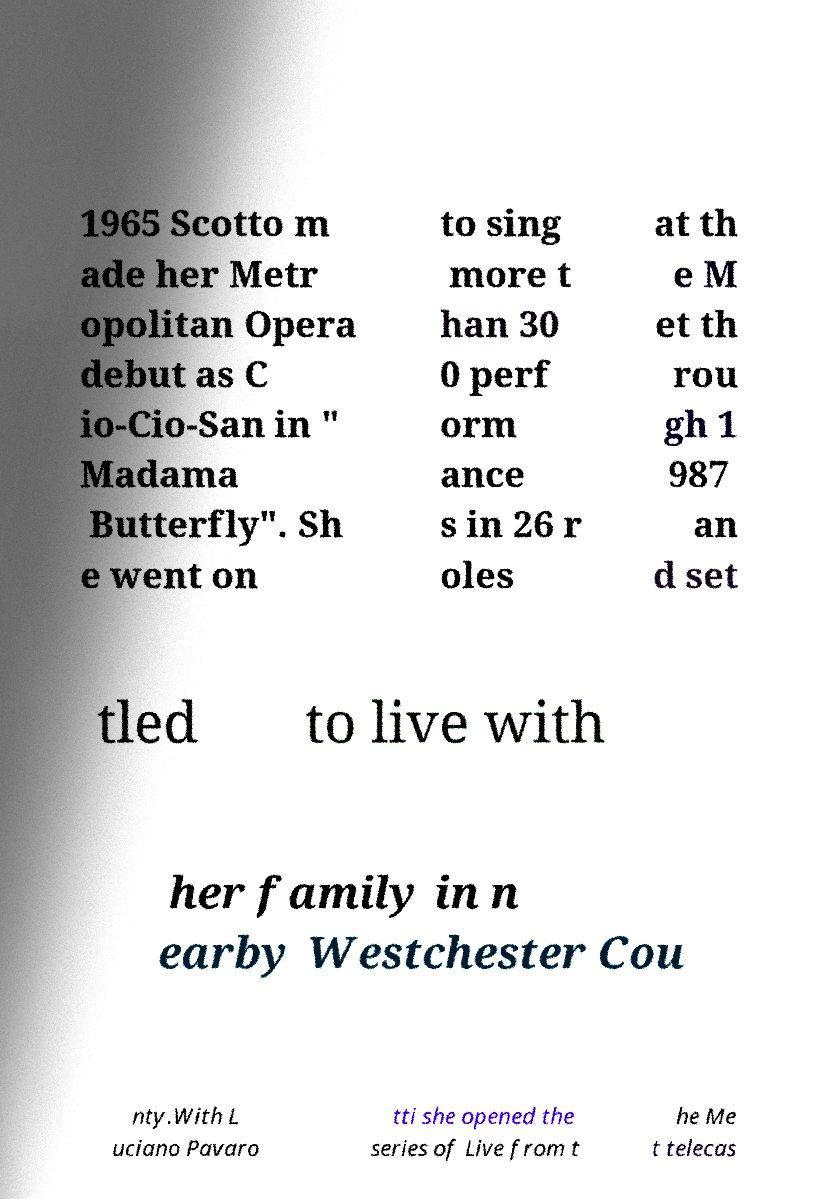Could you extract and type out the text from this image? 1965 Scotto m ade her Metr opolitan Opera debut as C io-Cio-San in " Madama Butterfly". Sh e went on to sing more t han 30 0 perf orm ance s in 26 r oles at th e M et th rou gh 1 987 an d set tled to live with her family in n earby Westchester Cou nty.With L uciano Pavaro tti she opened the series of Live from t he Me t telecas 